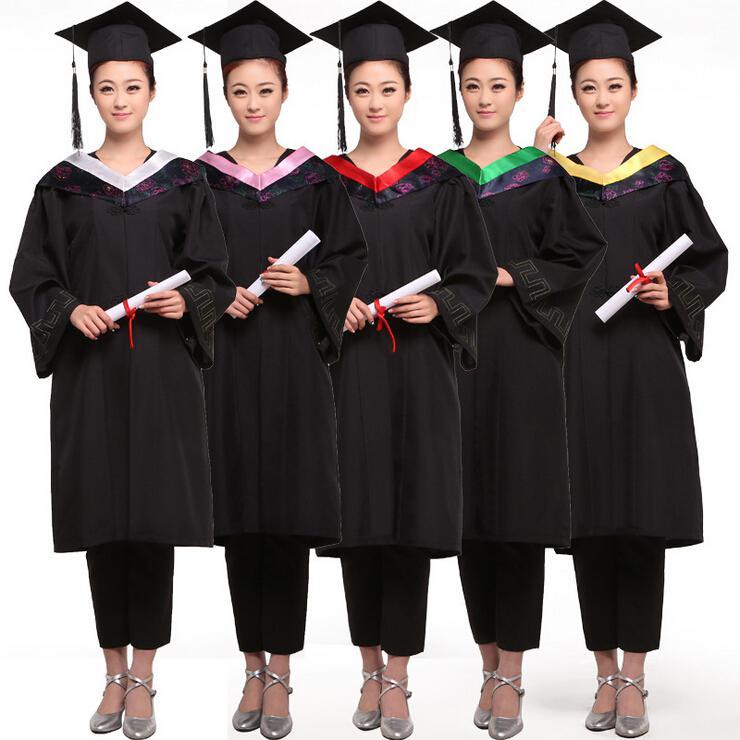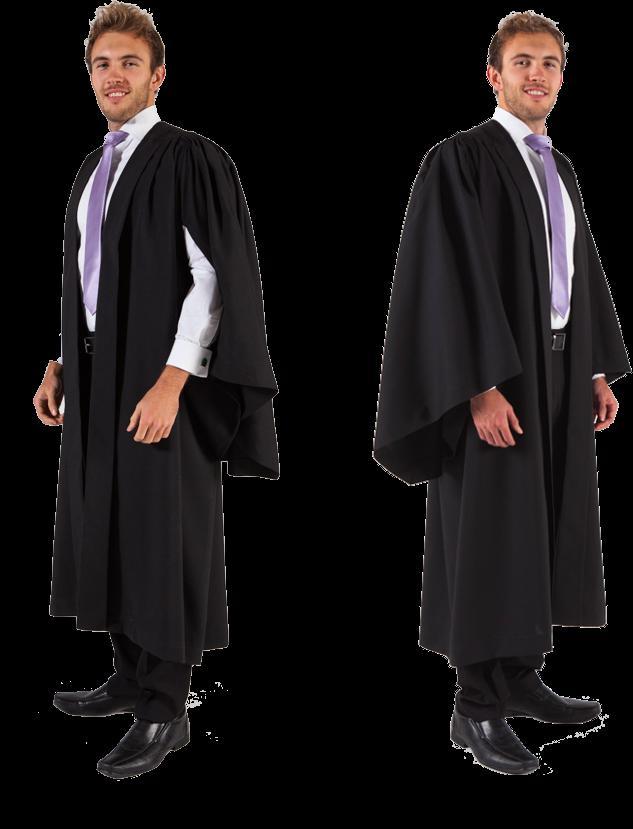The first image is the image on the left, the second image is the image on the right. Assess this claim about the two images: "One photo has at least one male wearing a purple tie that is visible.". Correct or not? Answer yes or no. Yes. The first image is the image on the left, the second image is the image on the right. Analyze the images presented: Is the assertion "The left image contains at least 4 students in gowns, and you can see their entire body, head to foot." valid? Answer yes or no. Yes. The first image is the image on the left, the second image is the image on the right. Examine the images to the left and right. Is the description "There are two people in graduation-type robes in the left image." accurate? Answer yes or no. Yes. 